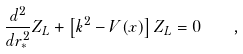Convert formula to latex. <formula><loc_0><loc_0><loc_500><loc_500>\frac { d ^ { 2 } } { d r _ { * } ^ { 2 } } Z _ { L } + \left [ k ^ { 2 } - V ( x ) \right ] Z _ { L } = 0 \quad ,</formula> 